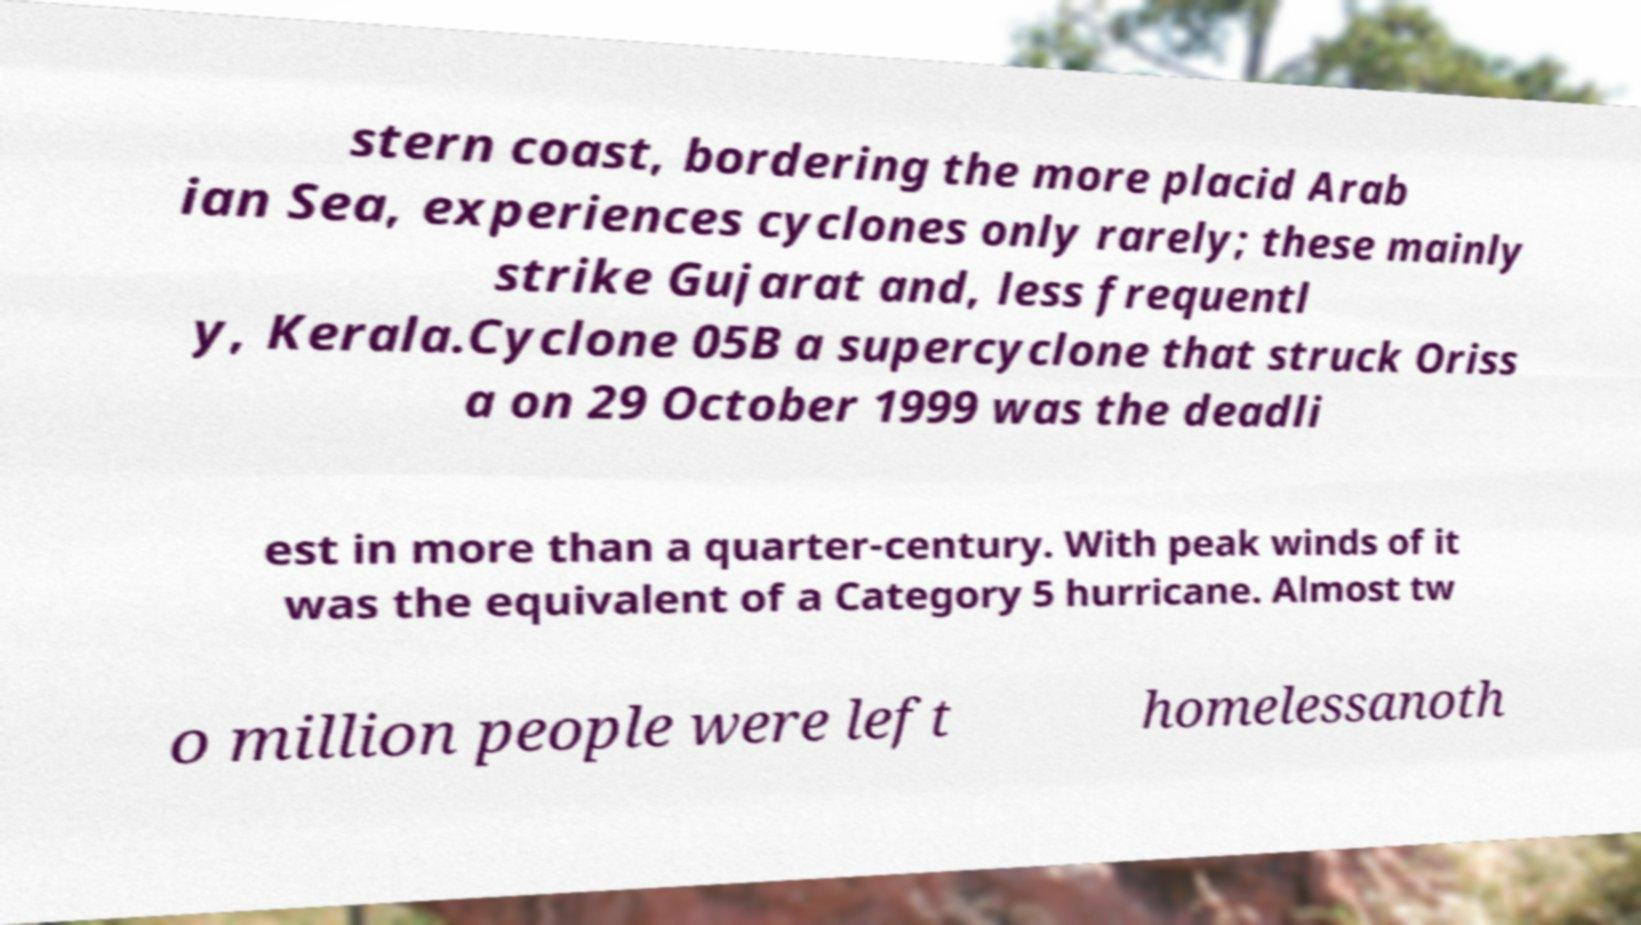What messages or text are displayed in this image? I need them in a readable, typed format. stern coast, bordering the more placid Arab ian Sea, experiences cyclones only rarely; these mainly strike Gujarat and, less frequentl y, Kerala.Cyclone 05B a supercyclone that struck Oriss a on 29 October 1999 was the deadli est in more than a quarter-century. With peak winds of it was the equivalent of a Category 5 hurricane. Almost tw o million people were left homelessanoth 